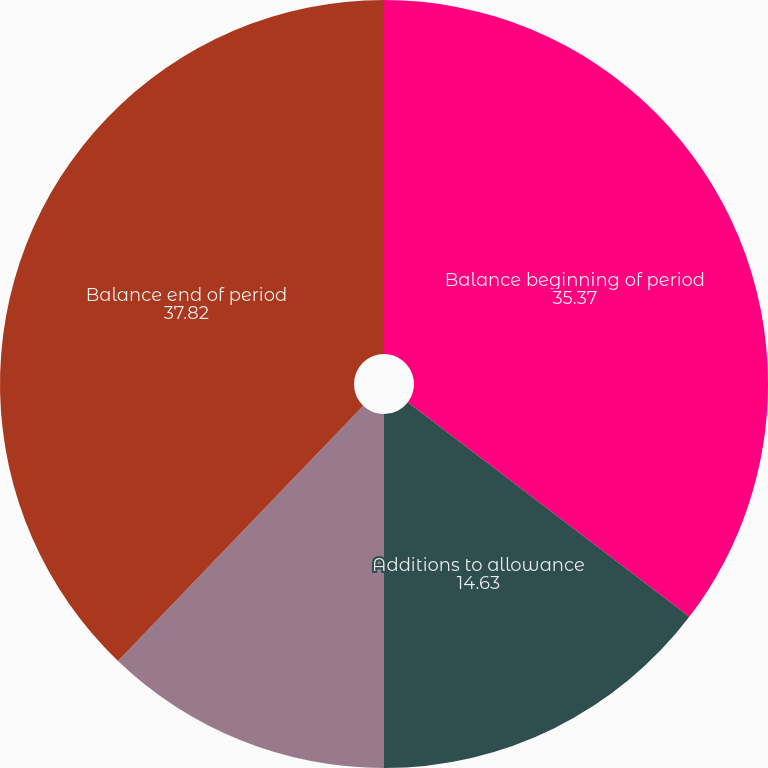Convert chart. <chart><loc_0><loc_0><loc_500><loc_500><pie_chart><fcel>Balance beginning of period<fcel>Additions to allowance<fcel>Deductions net of recoveries<fcel>Balance end of period<nl><fcel>35.37%<fcel>14.63%<fcel>12.18%<fcel>37.82%<nl></chart> 